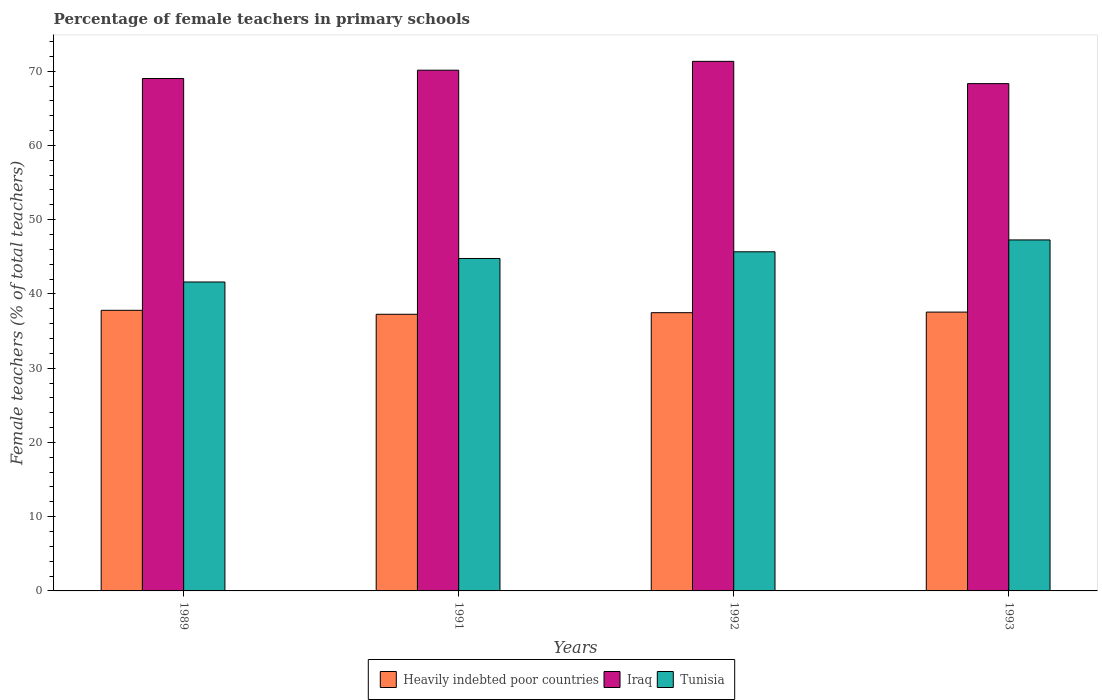How many different coloured bars are there?
Your answer should be very brief. 3. Are the number of bars per tick equal to the number of legend labels?
Your answer should be very brief. Yes. What is the percentage of female teachers in Iraq in 1989?
Your response must be concise. 69.01. Across all years, what is the maximum percentage of female teachers in Iraq?
Ensure brevity in your answer.  71.32. Across all years, what is the minimum percentage of female teachers in Iraq?
Offer a terse response. 68.32. In which year was the percentage of female teachers in Iraq maximum?
Offer a terse response. 1992. What is the total percentage of female teachers in Heavily indebted poor countries in the graph?
Your response must be concise. 150.07. What is the difference between the percentage of female teachers in Iraq in 1992 and that in 1993?
Your response must be concise. 3. What is the difference between the percentage of female teachers in Heavily indebted poor countries in 1992 and the percentage of female teachers in Iraq in 1989?
Your answer should be compact. -31.54. What is the average percentage of female teachers in Iraq per year?
Offer a very short reply. 69.69. In the year 1993, what is the difference between the percentage of female teachers in Tunisia and percentage of female teachers in Heavily indebted poor countries?
Provide a short and direct response. 9.72. In how many years, is the percentage of female teachers in Iraq greater than 50 %?
Your answer should be very brief. 4. What is the ratio of the percentage of female teachers in Iraq in 1992 to that in 1993?
Make the answer very short. 1.04. Is the percentage of female teachers in Iraq in 1989 less than that in 1993?
Provide a succinct answer. No. Is the difference between the percentage of female teachers in Tunisia in 1989 and 1992 greater than the difference between the percentage of female teachers in Heavily indebted poor countries in 1989 and 1992?
Ensure brevity in your answer.  No. What is the difference between the highest and the second highest percentage of female teachers in Tunisia?
Offer a very short reply. 1.6. What is the difference between the highest and the lowest percentage of female teachers in Heavily indebted poor countries?
Your answer should be very brief. 0.53. In how many years, is the percentage of female teachers in Iraq greater than the average percentage of female teachers in Iraq taken over all years?
Ensure brevity in your answer.  2. What does the 2nd bar from the left in 1991 represents?
Keep it short and to the point. Iraq. What does the 2nd bar from the right in 1993 represents?
Offer a very short reply. Iraq. Is it the case that in every year, the sum of the percentage of female teachers in Heavily indebted poor countries and percentage of female teachers in Iraq is greater than the percentage of female teachers in Tunisia?
Give a very brief answer. Yes. Are all the bars in the graph horizontal?
Offer a terse response. No. How many years are there in the graph?
Make the answer very short. 4. Are the values on the major ticks of Y-axis written in scientific E-notation?
Ensure brevity in your answer.  No. Does the graph contain any zero values?
Provide a short and direct response. No. Does the graph contain grids?
Offer a very short reply. No. How are the legend labels stacked?
Provide a succinct answer. Horizontal. What is the title of the graph?
Provide a succinct answer. Percentage of female teachers in primary schools. Does "St. Kitts and Nevis" appear as one of the legend labels in the graph?
Offer a terse response. No. What is the label or title of the Y-axis?
Give a very brief answer. Female teachers (% of total teachers). What is the Female teachers (% of total teachers) in Heavily indebted poor countries in 1989?
Keep it short and to the point. 37.79. What is the Female teachers (% of total teachers) of Iraq in 1989?
Offer a terse response. 69.01. What is the Female teachers (% of total teachers) of Tunisia in 1989?
Make the answer very short. 41.61. What is the Female teachers (% of total teachers) in Heavily indebted poor countries in 1991?
Give a very brief answer. 37.26. What is the Female teachers (% of total teachers) in Iraq in 1991?
Ensure brevity in your answer.  70.13. What is the Female teachers (% of total teachers) of Tunisia in 1991?
Make the answer very short. 44.77. What is the Female teachers (% of total teachers) in Heavily indebted poor countries in 1992?
Make the answer very short. 37.47. What is the Female teachers (% of total teachers) in Iraq in 1992?
Your answer should be compact. 71.32. What is the Female teachers (% of total teachers) of Tunisia in 1992?
Provide a short and direct response. 45.67. What is the Female teachers (% of total teachers) of Heavily indebted poor countries in 1993?
Make the answer very short. 37.55. What is the Female teachers (% of total teachers) of Iraq in 1993?
Offer a terse response. 68.32. What is the Female teachers (% of total teachers) in Tunisia in 1993?
Offer a very short reply. 47.27. Across all years, what is the maximum Female teachers (% of total teachers) of Heavily indebted poor countries?
Your answer should be very brief. 37.79. Across all years, what is the maximum Female teachers (% of total teachers) of Iraq?
Provide a short and direct response. 71.32. Across all years, what is the maximum Female teachers (% of total teachers) of Tunisia?
Your answer should be compact. 47.27. Across all years, what is the minimum Female teachers (% of total teachers) of Heavily indebted poor countries?
Your response must be concise. 37.26. Across all years, what is the minimum Female teachers (% of total teachers) of Iraq?
Your response must be concise. 68.32. Across all years, what is the minimum Female teachers (% of total teachers) of Tunisia?
Offer a very short reply. 41.61. What is the total Female teachers (% of total teachers) of Heavily indebted poor countries in the graph?
Your response must be concise. 150.07. What is the total Female teachers (% of total teachers) of Iraq in the graph?
Offer a terse response. 278.78. What is the total Female teachers (% of total teachers) in Tunisia in the graph?
Your answer should be compact. 179.32. What is the difference between the Female teachers (% of total teachers) in Heavily indebted poor countries in 1989 and that in 1991?
Make the answer very short. 0.53. What is the difference between the Female teachers (% of total teachers) of Iraq in 1989 and that in 1991?
Make the answer very short. -1.12. What is the difference between the Female teachers (% of total teachers) of Tunisia in 1989 and that in 1991?
Keep it short and to the point. -3.17. What is the difference between the Female teachers (% of total teachers) in Heavily indebted poor countries in 1989 and that in 1992?
Provide a short and direct response. 0.32. What is the difference between the Female teachers (% of total teachers) of Iraq in 1989 and that in 1992?
Make the answer very short. -2.31. What is the difference between the Female teachers (% of total teachers) in Tunisia in 1989 and that in 1992?
Make the answer very short. -4.07. What is the difference between the Female teachers (% of total teachers) in Heavily indebted poor countries in 1989 and that in 1993?
Give a very brief answer. 0.24. What is the difference between the Female teachers (% of total teachers) in Iraq in 1989 and that in 1993?
Give a very brief answer. 0.69. What is the difference between the Female teachers (% of total teachers) in Tunisia in 1989 and that in 1993?
Your response must be concise. -5.67. What is the difference between the Female teachers (% of total teachers) in Heavily indebted poor countries in 1991 and that in 1992?
Your answer should be very brief. -0.21. What is the difference between the Female teachers (% of total teachers) in Iraq in 1991 and that in 1992?
Keep it short and to the point. -1.19. What is the difference between the Female teachers (% of total teachers) of Tunisia in 1991 and that in 1992?
Your response must be concise. -0.9. What is the difference between the Female teachers (% of total teachers) of Heavily indebted poor countries in 1991 and that in 1993?
Your response must be concise. -0.29. What is the difference between the Female teachers (% of total teachers) of Iraq in 1991 and that in 1993?
Keep it short and to the point. 1.81. What is the difference between the Female teachers (% of total teachers) in Tunisia in 1991 and that in 1993?
Make the answer very short. -2.5. What is the difference between the Female teachers (% of total teachers) in Heavily indebted poor countries in 1992 and that in 1993?
Ensure brevity in your answer.  -0.08. What is the difference between the Female teachers (% of total teachers) in Iraq in 1992 and that in 1993?
Your answer should be compact. 3. What is the difference between the Female teachers (% of total teachers) in Tunisia in 1992 and that in 1993?
Ensure brevity in your answer.  -1.6. What is the difference between the Female teachers (% of total teachers) in Heavily indebted poor countries in 1989 and the Female teachers (% of total teachers) in Iraq in 1991?
Offer a terse response. -32.34. What is the difference between the Female teachers (% of total teachers) in Heavily indebted poor countries in 1989 and the Female teachers (% of total teachers) in Tunisia in 1991?
Offer a very short reply. -6.98. What is the difference between the Female teachers (% of total teachers) of Iraq in 1989 and the Female teachers (% of total teachers) of Tunisia in 1991?
Keep it short and to the point. 24.23. What is the difference between the Female teachers (% of total teachers) in Heavily indebted poor countries in 1989 and the Female teachers (% of total teachers) in Iraq in 1992?
Keep it short and to the point. -33.53. What is the difference between the Female teachers (% of total teachers) of Heavily indebted poor countries in 1989 and the Female teachers (% of total teachers) of Tunisia in 1992?
Provide a succinct answer. -7.88. What is the difference between the Female teachers (% of total teachers) in Iraq in 1989 and the Female teachers (% of total teachers) in Tunisia in 1992?
Your answer should be very brief. 23.34. What is the difference between the Female teachers (% of total teachers) of Heavily indebted poor countries in 1989 and the Female teachers (% of total teachers) of Iraq in 1993?
Your answer should be very brief. -30.53. What is the difference between the Female teachers (% of total teachers) in Heavily indebted poor countries in 1989 and the Female teachers (% of total teachers) in Tunisia in 1993?
Your answer should be compact. -9.48. What is the difference between the Female teachers (% of total teachers) in Iraq in 1989 and the Female teachers (% of total teachers) in Tunisia in 1993?
Your response must be concise. 21.74. What is the difference between the Female teachers (% of total teachers) of Heavily indebted poor countries in 1991 and the Female teachers (% of total teachers) of Iraq in 1992?
Ensure brevity in your answer.  -34.06. What is the difference between the Female teachers (% of total teachers) in Heavily indebted poor countries in 1991 and the Female teachers (% of total teachers) in Tunisia in 1992?
Your answer should be compact. -8.41. What is the difference between the Female teachers (% of total teachers) in Iraq in 1991 and the Female teachers (% of total teachers) in Tunisia in 1992?
Ensure brevity in your answer.  24.46. What is the difference between the Female teachers (% of total teachers) in Heavily indebted poor countries in 1991 and the Female teachers (% of total teachers) in Iraq in 1993?
Keep it short and to the point. -31.06. What is the difference between the Female teachers (% of total teachers) in Heavily indebted poor countries in 1991 and the Female teachers (% of total teachers) in Tunisia in 1993?
Provide a succinct answer. -10.01. What is the difference between the Female teachers (% of total teachers) of Iraq in 1991 and the Female teachers (% of total teachers) of Tunisia in 1993?
Provide a short and direct response. 22.86. What is the difference between the Female teachers (% of total teachers) in Heavily indebted poor countries in 1992 and the Female teachers (% of total teachers) in Iraq in 1993?
Make the answer very short. -30.85. What is the difference between the Female teachers (% of total teachers) of Heavily indebted poor countries in 1992 and the Female teachers (% of total teachers) of Tunisia in 1993?
Provide a succinct answer. -9.8. What is the difference between the Female teachers (% of total teachers) in Iraq in 1992 and the Female teachers (% of total teachers) in Tunisia in 1993?
Offer a terse response. 24.05. What is the average Female teachers (% of total teachers) of Heavily indebted poor countries per year?
Offer a terse response. 37.52. What is the average Female teachers (% of total teachers) in Iraq per year?
Offer a terse response. 69.69. What is the average Female teachers (% of total teachers) in Tunisia per year?
Provide a short and direct response. 44.83. In the year 1989, what is the difference between the Female teachers (% of total teachers) in Heavily indebted poor countries and Female teachers (% of total teachers) in Iraq?
Give a very brief answer. -31.22. In the year 1989, what is the difference between the Female teachers (% of total teachers) of Heavily indebted poor countries and Female teachers (% of total teachers) of Tunisia?
Make the answer very short. -3.82. In the year 1989, what is the difference between the Female teachers (% of total teachers) of Iraq and Female teachers (% of total teachers) of Tunisia?
Your response must be concise. 27.4. In the year 1991, what is the difference between the Female teachers (% of total teachers) in Heavily indebted poor countries and Female teachers (% of total teachers) in Iraq?
Offer a terse response. -32.87. In the year 1991, what is the difference between the Female teachers (% of total teachers) in Heavily indebted poor countries and Female teachers (% of total teachers) in Tunisia?
Provide a succinct answer. -7.51. In the year 1991, what is the difference between the Female teachers (% of total teachers) in Iraq and Female teachers (% of total teachers) in Tunisia?
Offer a terse response. 25.36. In the year 1992, what is the difference between the Female teachers (% of total teachers) in Heavily indebted poor countries and Female teachers (% of total teachers) in Iraq?
Your answer should be very brief. -33.85. In the year 1992, what is the difference between the Female teachers (% of total teachers) of Heavily indebted poor countries and Female teachers (% of total teachers) of Tunisia?
Offer a very short reply. -8.2. In the year 1992, what is the difference between the Female teachers (% of total teachers) in Iraq and Female teachers (% of total teachers) in Tunisia?
Offer a terse response. 25.65. In the year 1993, what is the difference between the Female teachers (% of total teachers) in Heavily indebted poor countries and Female teachers (% of total teachers) in Iraq?
Ensure brevity in your answer.  -30.77. In the year 1993, what is the difference between the Female teachers (% of total teachers) in Heavily indebted poor countries and Female teachers (% of total teachers) in Tunisia?
Provide a succinct answer. -9.72. In the year 1993, what is the difference between the Female teachers (% of total teachers) of Iraq and Female teachers (% of total teachers) of Tunisia?
Provide a succinct answer. 21.05. What is the ratio of the Female teachers (% of total teachers) of Heavily indebted poor countries in 1989 to that in 1991?
Ensure brevity in your answer.  1.01. What is the ratio of the Female teachers (% of total teachers) of Tunisia in 1989 to that in 1991?
Offer a terse response. 0.93. What is the ratio of the Female teachers (% of total teachers) of Heavily indebted poor countries in 1989 to that in 1992?
Ensure brevity in your answer.  1.01. What is the ratio of the Female teachers (% of total teachers) of Iraq in 1989 to that in 1992?
Provide a short and direct response. 0.97. What is the ratio of the Female teachers (% of total teachers) of Tunisia in 1989 to that in 1992?
Keep it short and to the point. 0.91. What is the ratio of the Female teachers (% of total teachers) of Heavily indebted poor countries in 1989 to that in 1993?
Offer a terse response. 1.01. What is the ratio of the Female teachers (% of total teachers) of Iraq in 1989 to that in 1993?
Keep it short and to the point. 1.01. What is the ratio of the Female teachers (% of total teachers) of Tunisia in 1989 to that in 1993?
Your answer should be compact. 0.88. What is the ratio of the Female teachers (% of total teachers) in Iraq in 1991 to that in 1992?
Your answer should be very brief. 0.98. What is the ratio of the Female teachers (% of total teachers) of Tunisia in 1991 to that in 1992?
Your answer should be compact. 0.98. What is the ratio of the Female teachers (% of total teachers) in Iraq in 1991 to that in 1993?
Your answer should be very brief. 1.03. What is the ratio of the Female teachers (% of total teachers) of Tunisia in 1991 to that in 1993?
Offer a terse response. 0.95. What is the ratio of the Female teachers (% of total teachers) in Iraq in 1992 to that in 1993?
Provide a short and direct response. 1.04. What is the ratio of the Female teachers (% of total teachers) in Tunisia in 1992 to that in 1993?
Keep it short and to the point. 0.97. What is the difference between the highest and the second highest Female teachers (% of total teachers) in Heavily indebted poor countries?
Give a very brief answer. 0.24. What is the difference between the highest and the second highest Female teachers (% of total teachers) of Iraq?
Your answer should be very brief. 1.19. What is the difference between the highest and the second highest Female teachers (% of total teachers) in Tunisia?
Your answer should be very brief. 1.6. What is the difference between the highest and the lowest Female teachers (% of total teachers) of Heavily indebted poor countries?
Your answer should be very brief. 0.53. What is the difference between the highest and the lowest Female teachers (% of total teachers) in Iraq?
Your answer should be very brief. 3. What is the difference between the highest and the lowest Female teachers (% of total teachers) of Tunisia?
Your answer should be very brief. 5.67. 